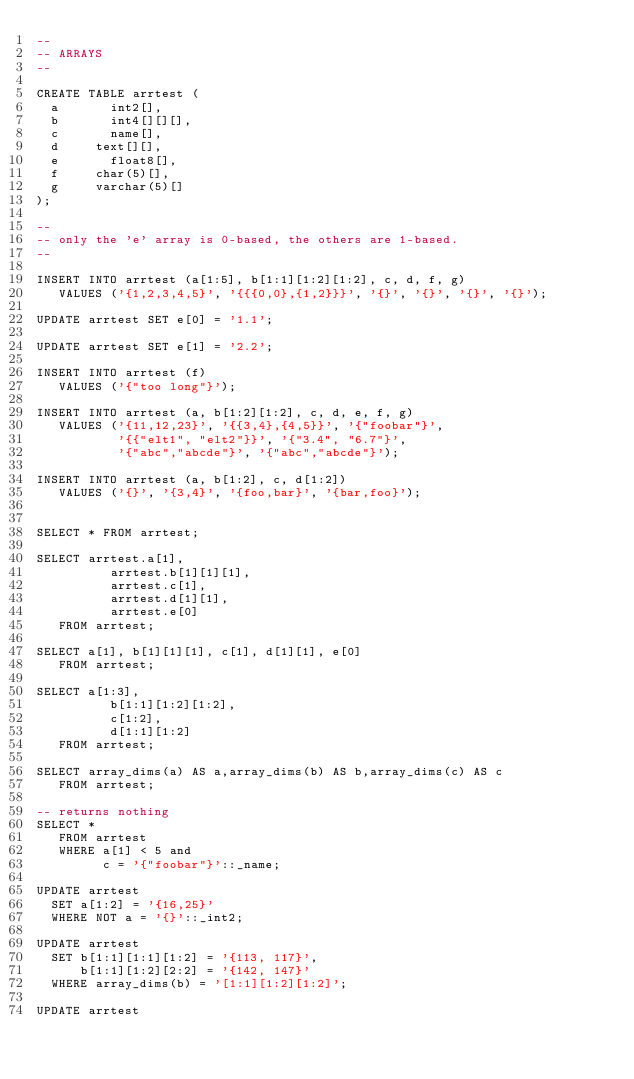Convert code to text. <code><loc_0><loc_0><loc_500><loc_500><_SQL_>--
-- ARRAYS
--

CREATE TABLE arrtest (
	a 			int2[],
	b 			int4[][][],
	c 			name[],
	d			text[][], 
	e 			float8[],
	f			char(5)[],
	g			varchar(5)[]
);

--
-- only the 'e' array is 0-based, the others are 1-based.
--

INSERT INTO arrtest (a[1:5], b[1:1][1:2][1:2], c, d, f, g)
   VALUES ('{1,2,3,4,5}', '{{{0,0},{1,2}}}', '{}', '{}', '{}', '{}');

UPDATE arrtest SET e[0] = '1.1';

UPDATE arrtest SET e[1] = '2.2';

INSERT INTO arrtest (f)
   VALUES ('{"too long"}');

INSERT INTO arrtest (a, b[1:2][1:2], c, d, e, f, g)
   VALUES ('{11,12,23}', '{{3,4},{4,5}}', '{"foobar"}', 
           '{{"elt1", "elt2"}}', '{"3.4", "6.7"}',
           '{"abc","abcde"}', '{"abc","abcde"}');

INSERT INTO arrtest (a, b[1:2], c, d[1:2])
   VALUES ('{}', '{3,4}', '{foo,bar}', '{bar,foo}');


SELECT * FROM arrtest;

SELECT arrtest.a[1],
          arrtest.b[1][1][1],
          arrtest.c[1],
          arrtest.d[1][1], 
          arrtest.e[0]
   FROM arrtest;

SELECT a[1], b[1][1][1], c[1], d[1][1], e[0]
   FROM arrtest;

SELECT a[1:3],
          b[1:1][1:2][1:2],
          c[1:2], 
          d[1:1][1:2]
   FROM arrtest;

SELECT array_dims(a) AS a,array_dims(b) AS b,array_dims(c) AS c
   FROM arrtest;

-- returns nothing 
SELECT *
   FROM arrtest
   WHERE a[1] < 5 and 
         c = '{"foobar"}'::_name;

UPDATE arrtest
  SET a[1:2] = '{16,25}'
  WHERE NOT a = '{}'::_int2;

UPDATE arrtest
  SET b[1:1][1:1][1:2] = '{113, 117}',
      b[1:1][1:2][2:2] = '{142, 147}'
  WHERE array_dims(b) = '[1:1][1:2][1:2]';

UPDATE arrtest</code> 